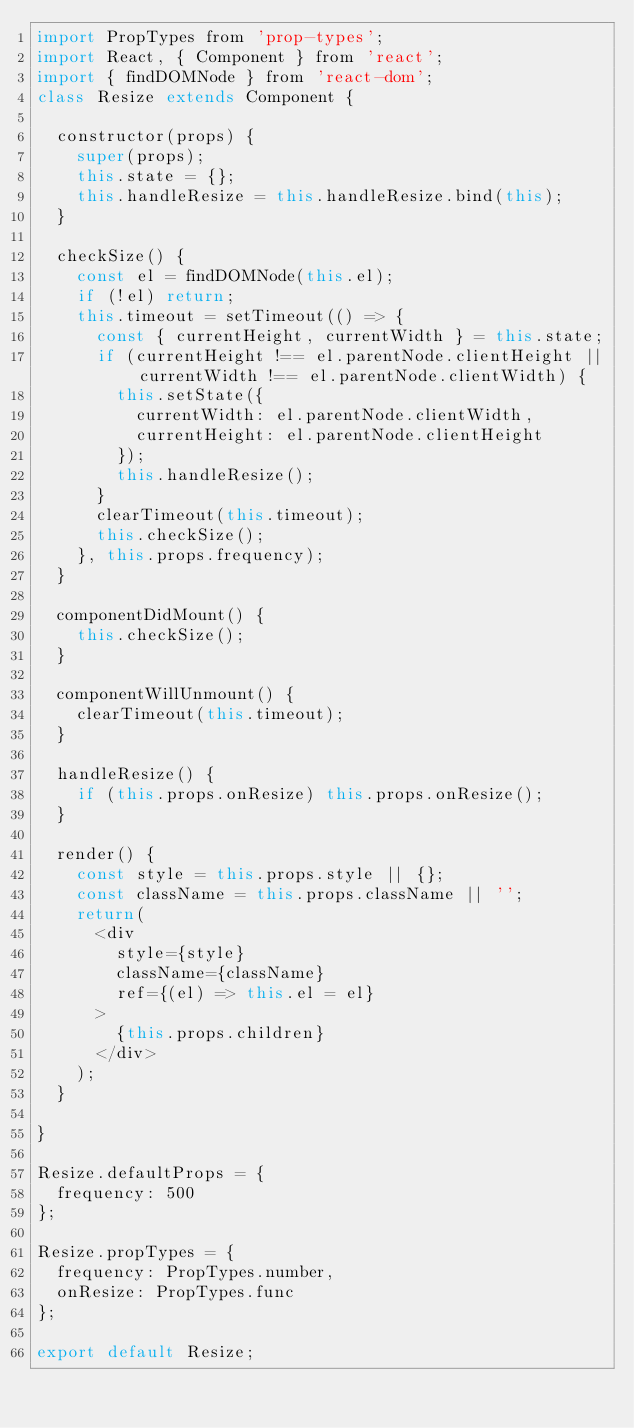<code> <loc_0><loc_0><loc_500><loc_500><_JavaScript_>import PropTypes from 'prop-types';
import React, { Component } from 'react';
import { findDOMNode } from 'react-dom';
class Resize extends Component {

  constructor(props) {
    super(props);
    this.state = {};
    this.handleResize = this.handleResize.bind(this);
  }

  checkSize() {
    const el = findDOMNode(this.el);
    if (!el) return;
    this.timeout = setTimeout(() => {
      const { currentHeight, currentWidth } = this.state;
      if (currentHeight !== el.parentNode.clientHeight || currentWidth !== el.parentNode.clientWidth) {
        this.setState({
          currentWidth: el.parentNode.clientWidth,
          currentHeight: el.parentNode.clientHeight
        });
        this.handleResize();
      }
      clearTimeout(this.timeout);
      this.checkSize();
    }, this.props.frequency);
  }

  componentDidMount() {
    this.checkSize();
  }

  componentWillUnmount() {
    clearTimeout(this.timeout);
  }

  handleResize() {
    if (this.props.onResize) this.props.onResize();
  }

  render() {
    const style = this.props.style || {};
    const className = this.props.className || '';
    return(
      <div
        style={style}
        className={className}
        ref={(el) => this.el = el}
      >
        {this.props.children}
      </div>
    );
  }

}

Resize.defaultProps = {
  frequency: 500
};

Resize.propTypes = {
  frequency: PropTypes.number,
  onResize: PropTypes.func
};

export default Resize;
</code> 